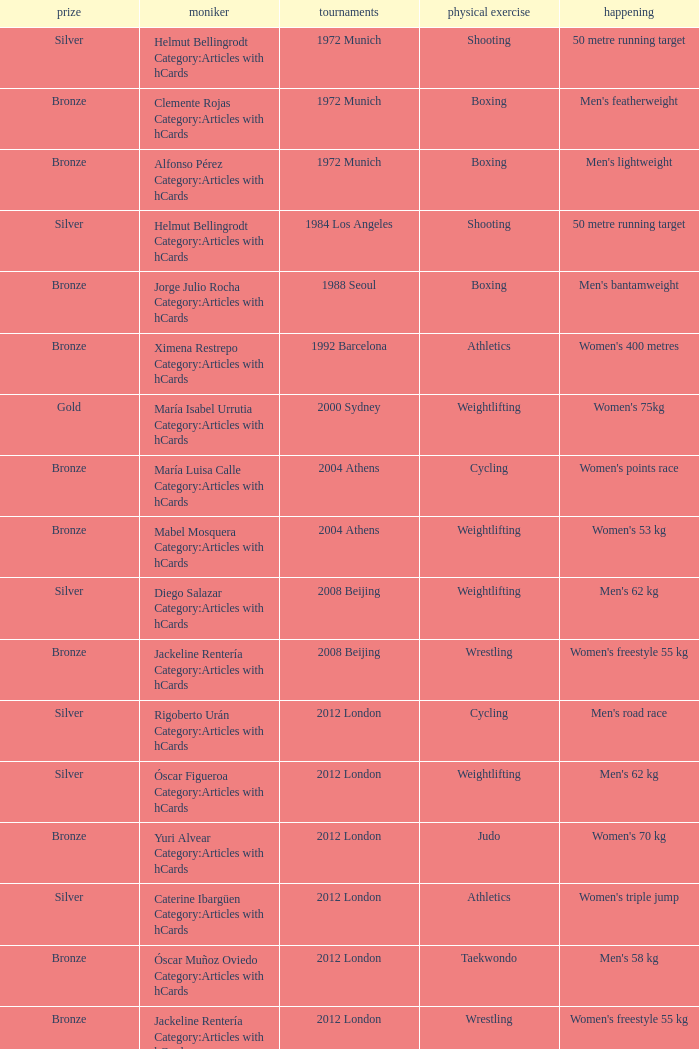Which sport resulted in a gold medal in the 2000 Sydney games? Weightlifting. 